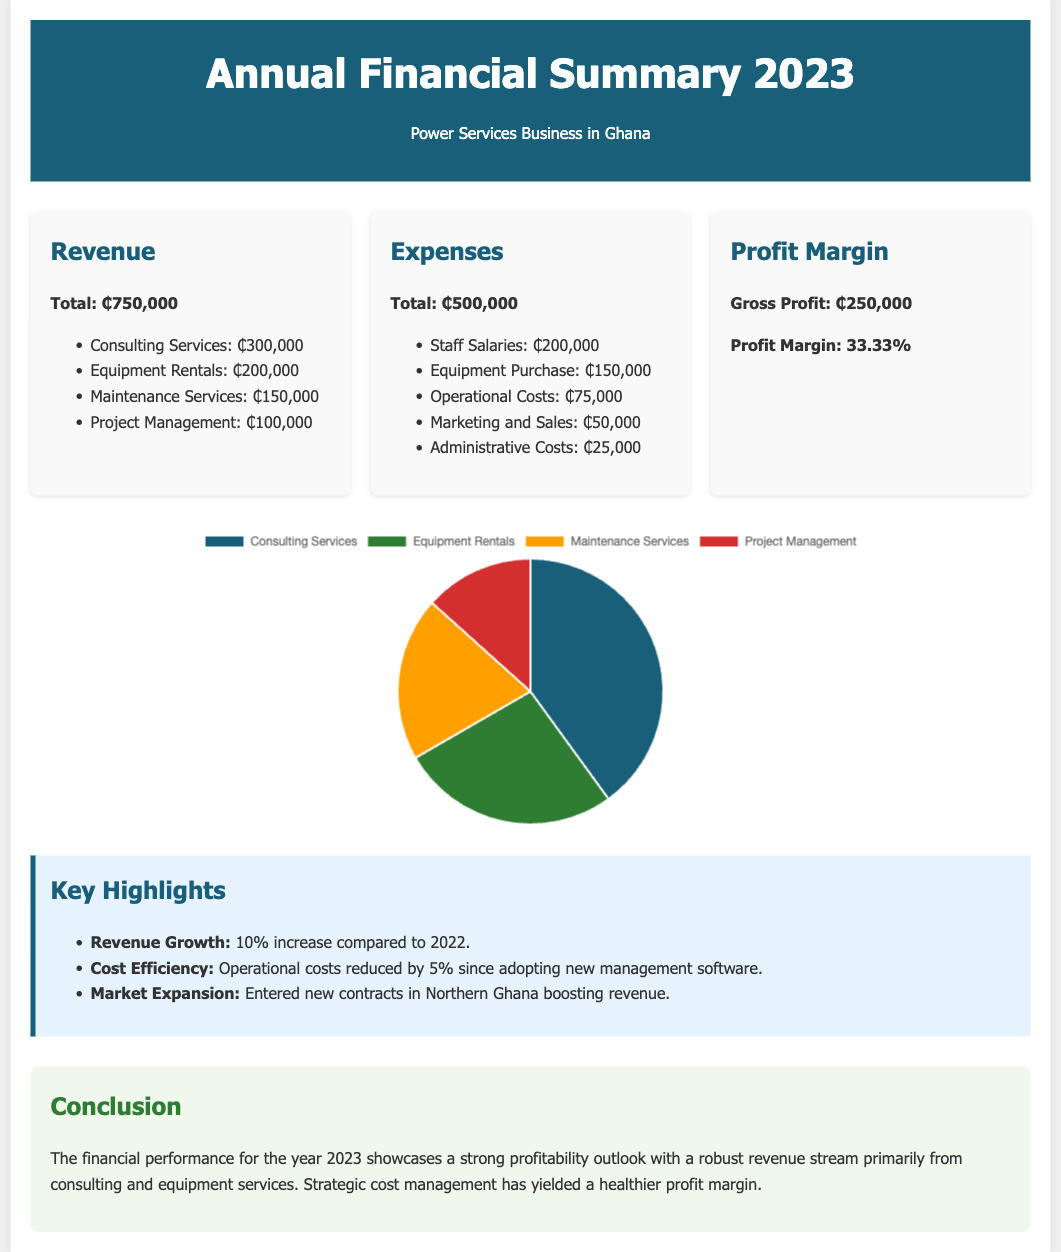What is the total revenue? The total revenue is the sum of all revenue sources in the document: ₵300,000 + ₵200,000 + ₵150,000 + ₵100,000 = ₵750,000.
Answer: ₵750,000 What is the total expense amount? The total expenses are calculated by summing all expense categories: ₵200,000 + ₵150,000 + ₵75,000 + ₵50,000 + ₵25,000 = ₵500,000.
Answer: ₵500,000 What is the gross profit? Gross profit is calculated by subtracting total expenses from total revenue: ₵750,000 - ₵500,000 = ₵250,000.
Answer: ₵250,000 What is the profit margin percentage? The profit margin is expressed as a percentage and is calculated by dividing the gross profit by total revenue: (₵250,000 / ₵750,000) * 100 = 33.33%.
Answer: 33.33% Which service generated the highest revenue? The information states that Consulting Services generated the highest revenue among the categories listed, at ₵300,000.
Answer: Consulting Services How much were the operational costs? The document specifies operational costs at ₵75,000.
Answer: ₵75,000 What was the revenue growth percentage? The document highlights a revenue growth of 10% compared to 2022.
Answer: 10% Which new area is mentioned for market expansion? The document states that the market expansion includes new contracts in Northern Ghana.
Answer: Northern Ghana What color represents Equipment Rentals in the revenue distribution chart? The color used to represent Equipment Rentals in the chart is green (#2e7d32).
Answer: green 